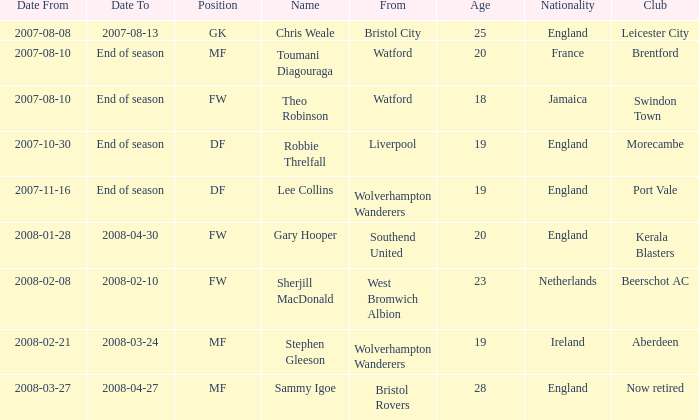What was the from for the Date From of 2007-08-08? Bristol City. 